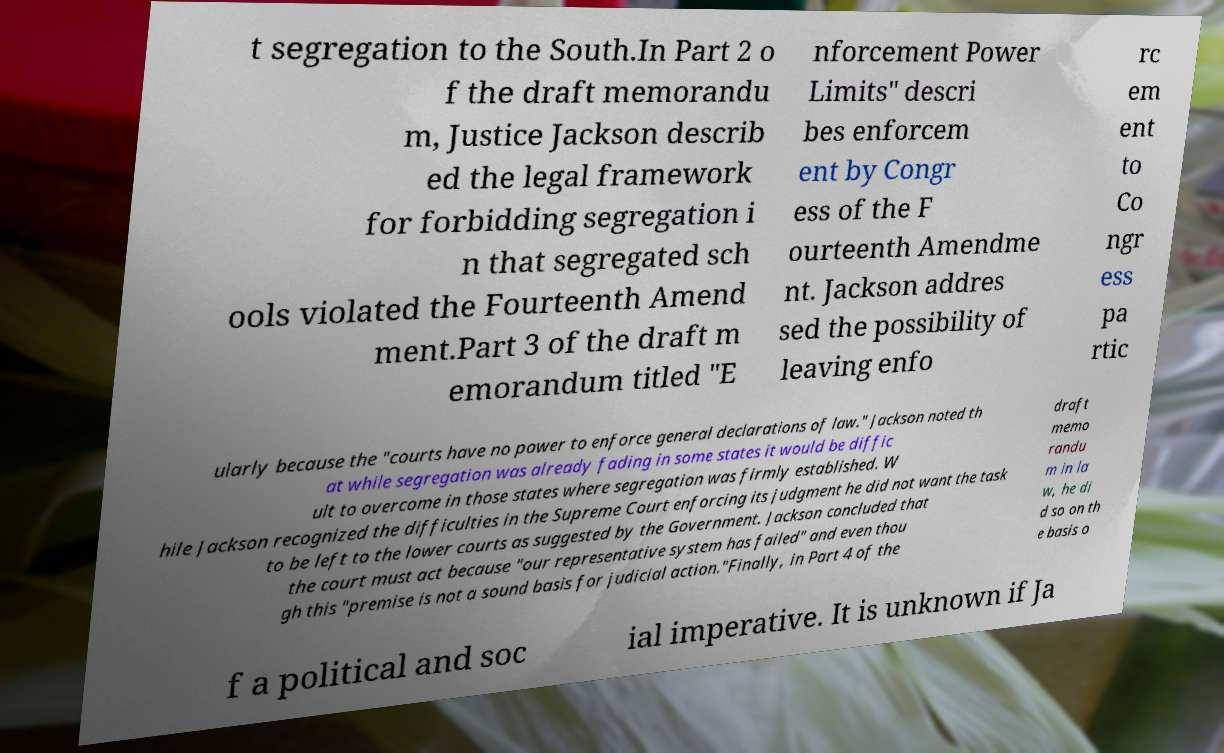For documentation purposes, I need the text within this image transcribed. Could you provide that? t segregation to the South.In Part 2 o f the draft memorandu m, Justice Jackson describ ed the legal framework for forbidding segregation i n that segregated sch ools violated the Fourteenth Amend ment.Part 3 of the draft m emorandum titled "E nforcement Power Limits" descri bes enforcem ent by Congr ess of the F ourteenth Amendme nt. Jackson addres sed the possibility of leaving enfo rc em ent to Co ngr ess pa rtic ularly because the "courts have no power to enforce general declarations of law." Jackson noted th at while segregation was already fading in some states it would be diffic ult to overcome in those states where segregation was firmly established. W hile Jackson recognized the difficulties in the Supreme Court enforcing its judgment he did not want the task to be left to the lower courts as suggested by the Government. Jackson concluded that the court must act because "our representative system has failed" and even thou gh this "premise is not a sound basis for judicial action."Finally, in Part 4 of the draft memo randu m in la w, he di d so on th e basis o f a political and soc ial imperative. It is unknown if Ja 